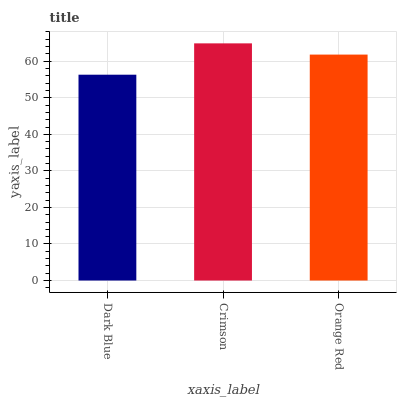Is Dark Blue the minimum?
Answer yes or no. Yes. Is Crimson the maximum?
Answer yes or no. Yes. Is Orange Red the minimum?
Answer yes or no. No. Is Orange Red the maximum?
Answer yes or no. No. Is Crimson greater than Orange Red?
Answer yes or no. Yes. Is Orange Red less than Crimson?
Answer yes or no. Yes. Is Orange Red greater than Crimson?
Answer yes or no. No. Is Crimson less than Orange Red?
Answer yes or no. No. Is Orange Red the high median?
Answer yes or no. Yes. Is Orange Red the low median?
Answer yes or no. Yes. Is Dark Blue the high median?
Answer yes or no. No. Is Crimson the low median?
Answer yes or no. No. 